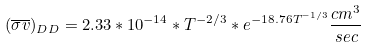Convert formula to latex. <formula><loc_0><loc_0><loc_500><loc_500>( { \overline { \sigma v } } ) _ { D D } = 2 . 3 3 * 1 0 ^ { - 1 4 } * T ^ { - 2 / 3 } * e ^ { - 1 8 . 7 6 T ^ { - 1 / 3 } } { \frac { { c m } ^ { 3 } } { s e c } }</formula> 